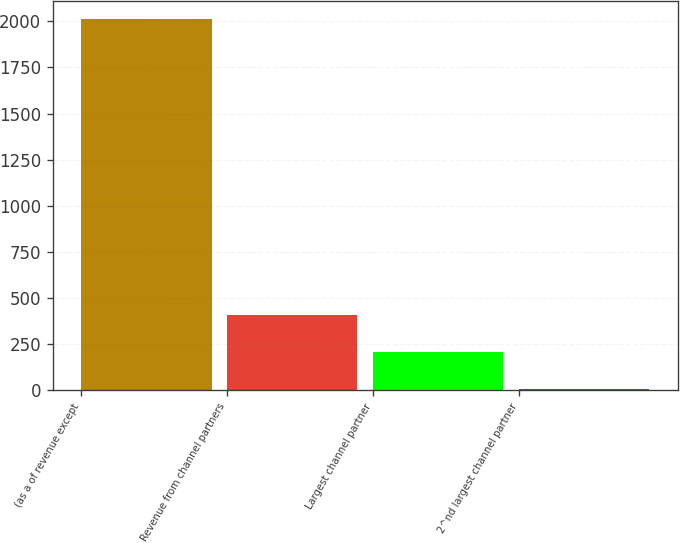Convert chart. <chart><loc_0><loc_0><loc_500><loc_500><bar_chart><fcel>(as a of revenue except<fcel>Revenue from channel partners<fcel>Largest channel partner<fcel>2^nd largest channel partner<nl><fcel>2012<fcel>404.8<fcel>203.9<fcel>3<nl></chart> 